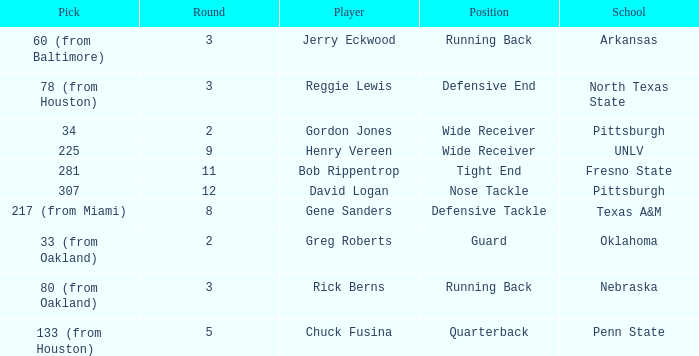What round was the nose tackle drafted? 12.0. 